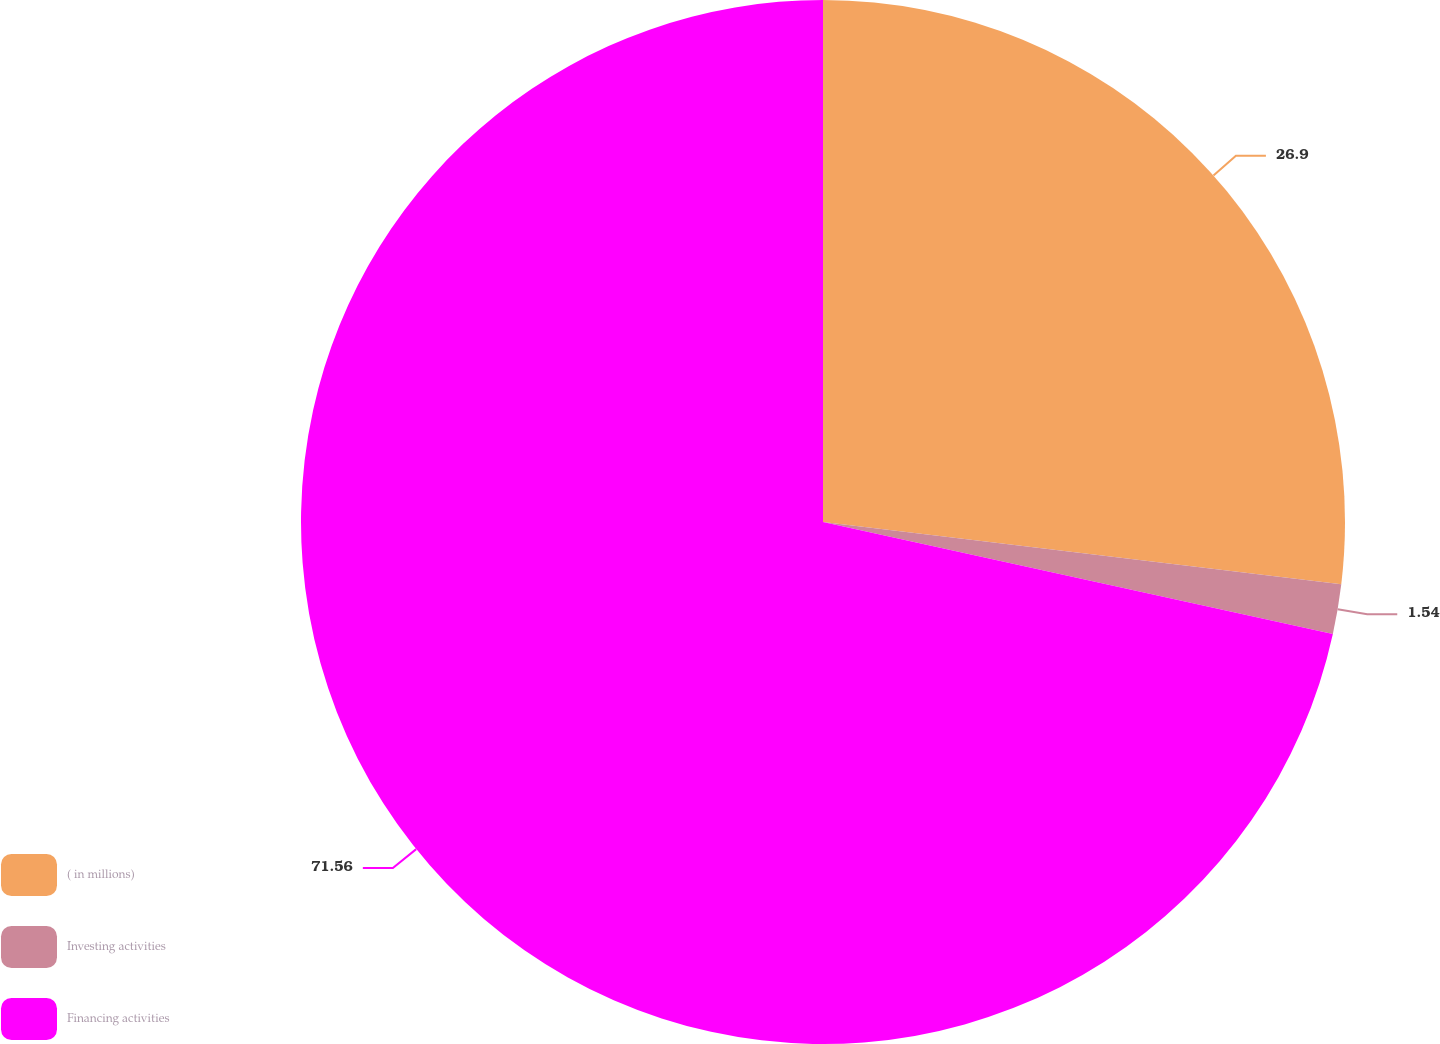Convert chart. <chart><loc_0><loc_0><loc_500><loc_500><pie_chart><fcel>( in millions)<fcel>Investing activities<fcel>Financing activities<nl><fcel>26.9%<fcel>1.54%<fcel>71.56%<nl></chart> 